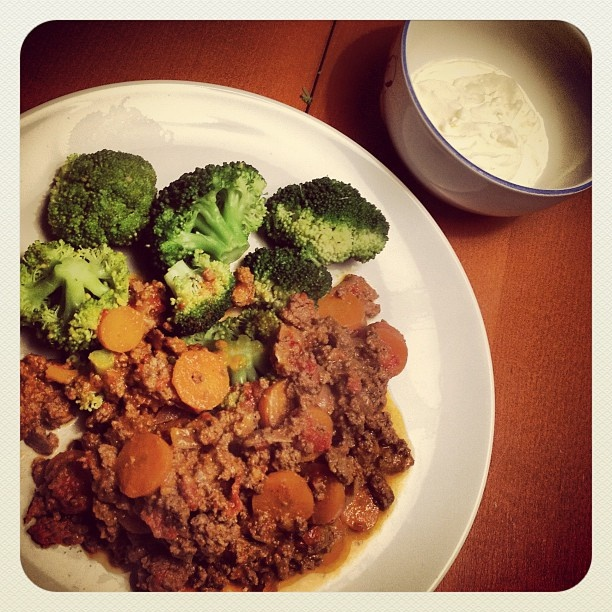Describe the objects in this image and their specific colors. I can see dining table in maroon, ivory, tan, black, and brown tones, bowl in ivory, khaki, maroon, brown, and tan tones, broccoli in ivory, olive, and black tones, broccoli in ivory, olive, black, and khaki tones, and broccoli in ivory, olive, black, darkgreen, and khaki tones in this image. 